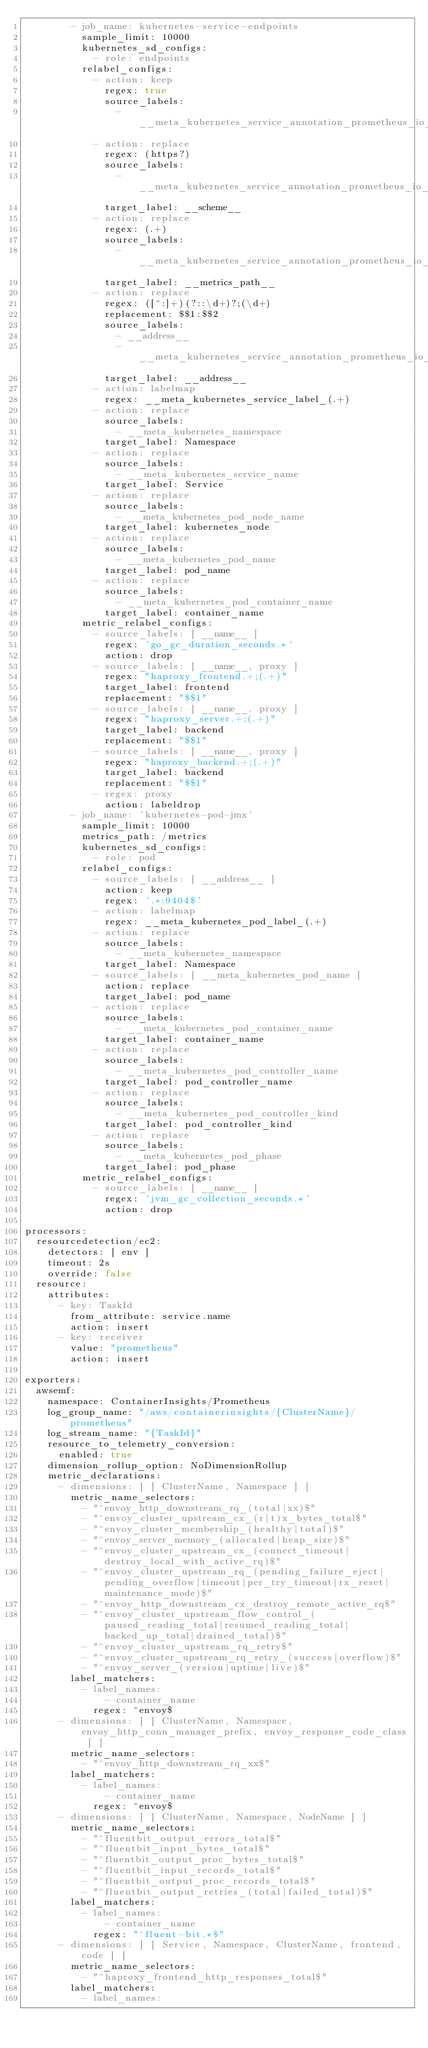<code> <loc_0><loc_0><loc_500><loc_500><_YAML_>        - job_name: kubernetes-service-endpoints
          sample_limit: 10000
          kubernetes_sd_configs:
            - role: endpoints
          relabel_configs:
            - action: keep
              regex: true
              source_labels:
                - __meta_kubernetes_service_annotation_prometheus_io_scrape
            - action: replace
              regex: (https?)
              source_labels:
                - __meta_kubernetes_service_annotation_prometheus_io_scheme
              target_label: __scheme__
            - action: replace
              regex: (.+)
              source_labels:
                - __meta_kubernetes_service_annotation_prometheus_io_path
              target_label: __metrics_path__
            - action: replace
              regex: ([^:]+)(?::\d+)?;(\d+)
              replacement: $$1:$$2
              source_labels:
                - __address__
                - __meta_kubernetes_service_annotation_prometheus_io_port
              target_label: __address__
            - action: labelmap
              regex: __meta_kubernetes_service_label_(.+)
            - action: replace
              source_labels:
                - __meta_kubernetes_namespace
              target_label: Namespace
            - action: replace
              source_labels:
                - __meta_kubernetes_service_name
              target_label: Service
            - action: replace
              source_labels:
                - __meta_kubernetes_pod_node_name
              target_label: kubernetes_node
            - action: replace
              source_labels:
                - __meta_kubernetes_pod_name
              target_label: pod_name
            - action: replace
              source_labels:
                - __meta_kubernetes_pod_container_name
              target_label: container_name
          metric_relabel_configs:
            - source_labels: [ __name__ ]
              regex: 'go_gc_duration_seconds.*'
              action: drop
            - source_labels: [ __name__, proxy ]
              regex: "haproxy_frontend.+;(.+)"
              target_label: frontend
              replacement: "$$1"
            - source_labels: [ __name__, proxy ]
              regex: "haproxy_server.+;(.+)"
              target_label: backend
              replacement: "$$1"
            - source_labels: [ __name__, proxy ]
              regex: "haproxy_backend.+;(.+)"
              target_label: backend
              replacement: "$$1"
            - regex: proxy
              action: labeldrop
        - job_name: 'kubernetes-pod-jmx'
          sample_limit: 10000
          metrics_path: /metrics
          kubernetes_sd_configs:
            - role: pod
          relabel_configs:
            - source_labels: [ __address__ ]
              action: keep
              regex: '.*:9404$'
            - action: labelmap
              regex: __meta_kubernetes_pod_label_(.+)
            - action: replace
              source_labels:
                - __meta_kubernetes_namespace
              target_label: Namespace
            - source_labels: [ __meta_kubernetes_pod_name ]
              action: replace
              target_label: pod_name
            - action: replace
              source_labels:
                - __meta_kubernetes_pod_container_name
              target_label: container_name
            - action: replace
              source_labels:
                - __meta_kubernetes_pod_controller_name
              target_label: pod_controller_name
            - action: replace
              source_labels:
                - __meta_kubernetes_pod_controller_kind
              target_label: pod_controller_kind
            - action: replace
              source_labels:
                - __meta_kubernetes_pod_phase
              target_label: pod_phase
          metric_relabel_configs:
            - source_labels: [ __name__ ]
              regex: 'jvm_gc_collection_seconds.*'
              action: drop

processors:
  resourcedetection/ec2:
    detectors: [ env ]
    timeout: 2s
    override: false
  resource:
    attributes:
      - key: TaskId
        from_attribute: service.name
        action: insert
      - key: receiver
        value: "prometheus"
        action: insert

exporters:
  awsemf:
    namespace: ContainerInsights/Prometheus
    log_group_name: "/aws/containerinsights/{ClusterName}/prometheus"
    log_stream_name: "{TaskId}"
    resource_to_telemetry_conversion:
      enabled: true
    dimension_rollup_option: NoDimensionRollup
    metric_declarations:
      - dimensions: [ [ ClusterName, Namespace ] ]
        metric_name_selectors:
          - "^envoy_http_downstream_rq_(total|xx)$"
          - "^envoy_cluster_upstream_cx_(r|t)x_bytes_total$"
          - "^envoy_cluster_membership_(healthy|total)$"
          - "^envoy_server_memory_(allocated|heap_size)$"
          - "^envoy_cluster_upstream_cx_(connect_timeout|destroy_local_with_active_rq)$"
          - "^envoy_cluster_upstream_rq_(pending_failure_eject|pending_overflow|timeout|per_try_timeout|rx_reset|maintenance_mode)$"
          - "^envoy_http_downstream_cx_destroy_remote_active_rq$"
          - "^envoy_cluster_upstream_flow_control_(paused_reading_total|resumed_reading_total|backed_up_total|drained_total)$"
          - "^envoy_cluster_upstream_rq_retry$"
          - "^envoy_cluster_upstream_rq_retry_(success|overflow)$"
          - "^envoy_server_(version|uptime|live)$"
        label_matchers:
          - label_names:
              - container_name
            regex: ^envoy$
      - dimensions: [ [ ClusterName, Namespace, envoy_http_conn_manager_prefix, envoy_response_code_class ] ]
        metric_name_selectors:
          - "^envoy_http_downstream_rq_xx$"
        label_matchers:
          - label_names:
              - container_name
            regex: ^envoy$
      - dimensions: [ [ ClusterName, Namespace, NodeName ] ]
        metric_name_selectors:
          - "^fluentbit_output_errors_total$"
          - "^fluentbit_input_bytes_total$"
          - "^fluentbit_output_proc_bytes_total$"
          - "^fluentbit_input_records_total$"
          - "^fluentbit_output_proc_records_total$"
          - "^fluentbit_output_retries_(total|failed_total)$"
        label_matchers:
          - label_names:
              - container_name
            regex: "^fluent-bit.*$"
      - dimensions: [ [ Service, Namespace, ClusterName, frontend, code ] ]
        metric_name_selectors:
          - "^haproxy_frontend_http_responses_total$"
        label_matchers:
          - label_names:</code> 